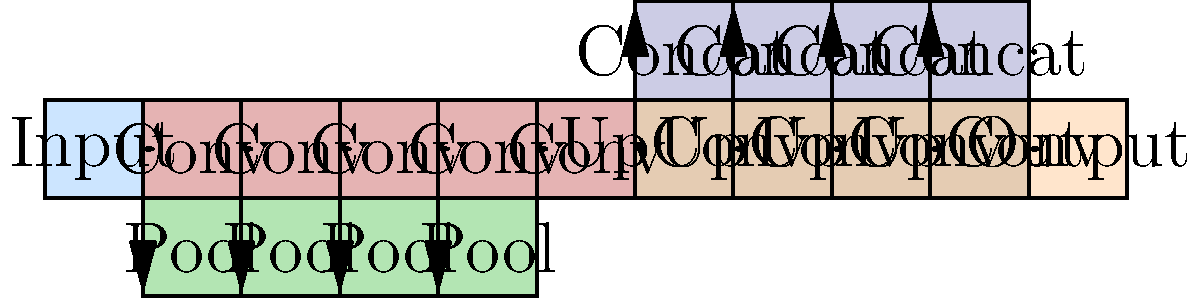In the U-Net architecture shown above for image segmentation, what is the primary purpose of the concatenation (Concat) operations in the expanding path? To understand the purpose of concatenation operations in U-Net, let's break down the architecture:

1. U-Net has a contracting path (left side) and an expanding path (right side).

2. The contracting path consists of repeated applications of:
   a) Convolutional layers (Conv)
   b) Pooling layers (Pool)

3. The expanding path consists of:
   a) Upsampling or transposed convolutions (UpConv)
   b) Concatenation operations (Concat)
   c) Regular convolutions

4. The concatenation operations serve several crucial purposes:

   a) They combine high-resolution features from the contracting path with upsampled features from the expanding path.
   
   b) This combination allows the network to use both local and global context information:
      - The contracting path captures global context.
      - The expanding path enables precise localization.

   c) The concatenation creates skip connections, which help to:
      - Recover spatial information lost during pooling operations
      - Mitigate the vanishing gradient problem during training
      - Improve the flow of information across the network

5. By concatenating these feature maps, the network can make more informed decisions about pixel-level classifications, leading to more accurate segmentation results.

6. This is particularly important in medical image segmentation, where precise boundary delineation is crucial.

In summary, the concatenation operations in U-Net allow the network to combine multi-scale features, preserving both contextual and spatial information, which is essential for accurate image segmentation.
Answer: To combine multi-scale features, preserving both contextual and spatial information for accurate segmentation. 